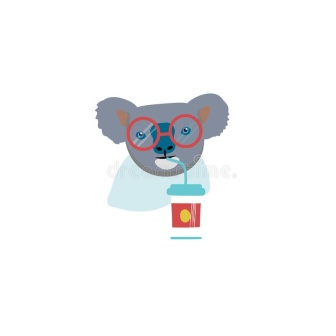Can you describe the artistic style used in this illustration? The illustration uses a flat, minimalist style characterized by clear outlines, solid colors, and a lack of texture or shading. This style emphasizes simplicity and clarity, making the image easily readable while focusing on the essential elements. The stark white background and the absence of unnecessary details ensure that the viewer's attention remains on the koala and its colorful accessories, thereby creating a strong visual impact with a contemporary feel. 